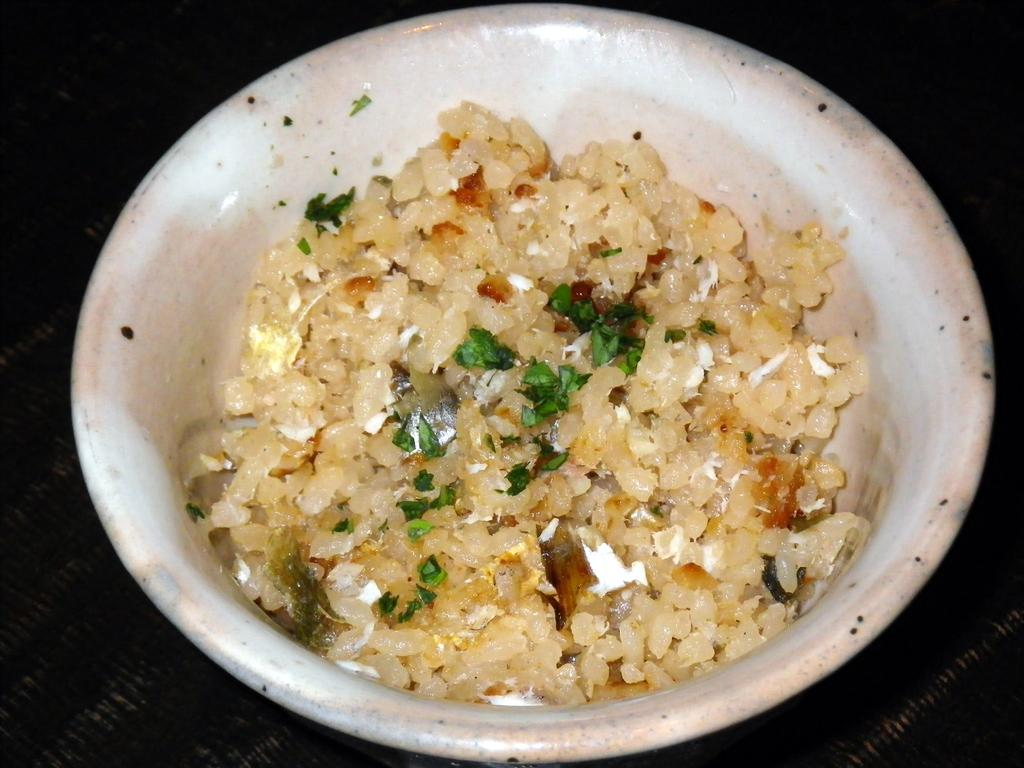What is present in the image related to food? There is food in the image. How is the food arranged or contained? The food is in a plate. Where is the plate with food located? The plate is placed on a table. What type of fruit can be seen on the bed in the image? There is no fruit or bed present in the image; it only features food in a plate placed on a table. 